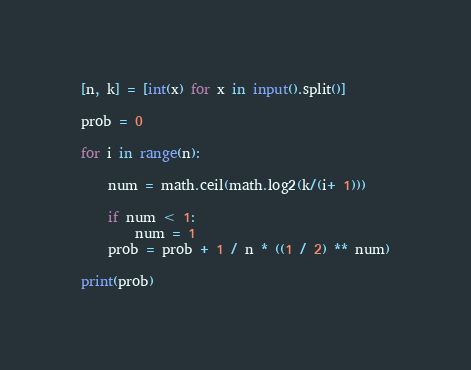Convert code to text. <code><loc_0><loc_0><loc_500><loc_500><_Python_>[n, k] = [int(x) for x in input().split()]

prob = 0

for i in range(n):
    
    num = math.ceil(math.log2(k/(i+ 1)))
    
    if num < 1:
        num = 1
    prob = prob + 1 / n * ((1 / 2) ** num)
    
print(prob)
</code> 